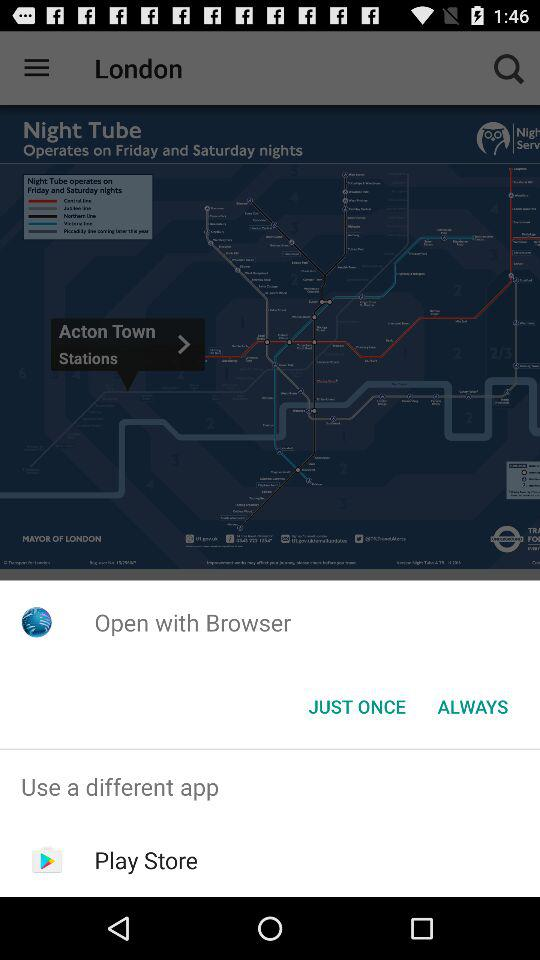What different apps can we use? We can use "Play Store". 